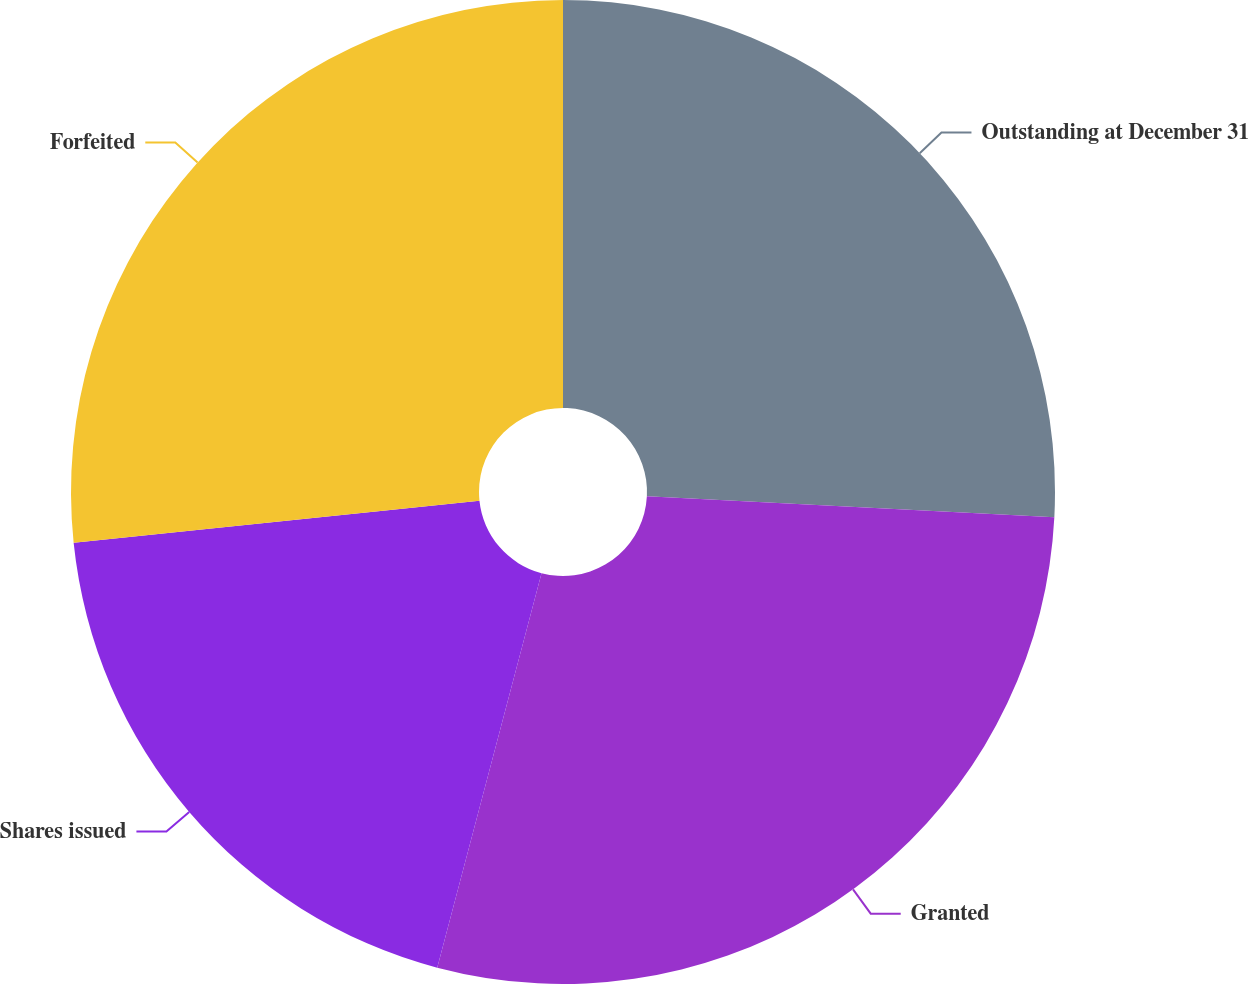Convert chart to OTSL. <chart><loc_0><loc_0><loc_500><loc_500><pie_chart><fcel>Outstanding at December 31<fcel>Granted<fcel>Shares issued<fcel>Forfeited<nl><fcel>25.82%<fcel>28.3%<fcel>19.24%<fcel>26.65%<nl></chart> 